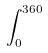<formula> <loc_0><loc_0><loc_500><loc_500>\int _ { 0 } ^ { 3 6 0 }</formula> 